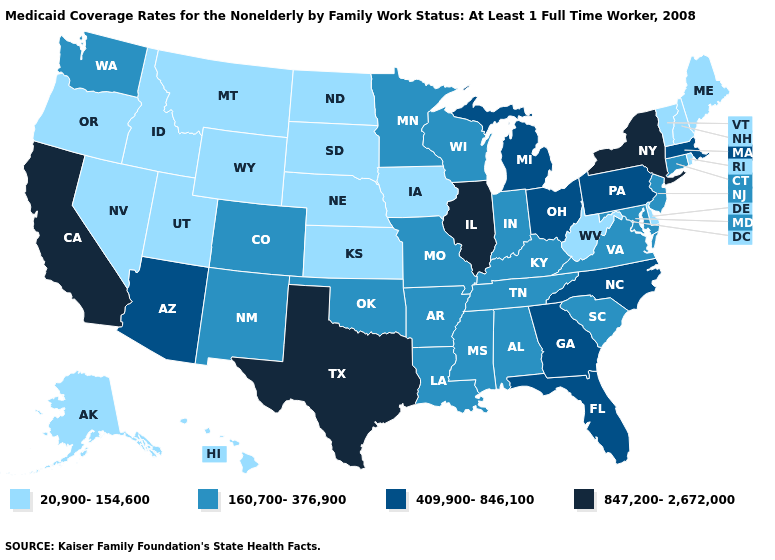Does Florida have the lowest value in the South?
Quick response, please. No. Name the states that have a value in the range 847,200-2,672,000?
Write a very short answer. California, Illinois, New York, Texas. What is the value of Alaska?
Quick response, please. 20,900-154,600. Name the states that have a value in the range 847,200-2,672,000?
Give a very brief answer. California, Illinois, New York, Texas. What is the value of Utah?
Keep it brief. 20,900-154,600. What is the highest value in the West ?
Quick response, please. 847,200-2,672,000. What is the highest value in the MidWest ?
Short answer required. 847,200-2,672,000. Name the states that have a value in the range 409,900-846,100?
Keep it brief. Arizona, Florida, Georgia, Massachusetts, Michigan, North Carolina, Ohio, Pennsylvania. Among the states that border Georgia , which have the highest value?
Short answer required. Florida, North Carolina. What is the value of South Dakota?
Answer briefly. 20,900-154,600. Does New Hampshire have the lowest value in the Northeast?
Short answer required. Yes. Which states have the lowest value in the USA?
Write a very short answer. Alaska, Delaware, Hawaii, Idaho, Iowa, Kansas, Maine, Montana, Nebraska, Nevada, New Hampshire, North Dakota, Oregon, Rhode Island, South Dakota, Utah, Vermont, West Virginia, Wyoming. Does Illinois have the highest value in the USA?
Give a very brief answer. Yes. Does Ohio have the lowest value in the MidWest?
Write a very short answer. No. Name the states that have a value in the range 20,900-154,600?
Quick response, please. Alaska, Delaware, Hawaii, Idaho, Iowa, Kansas, Maine, Montana, Nebraska, Nevada, New Hampshire, North Dakota, Oregon, Rhode Island, South Dakota, Utah, Vermont, West Virginia, Wyoming. 